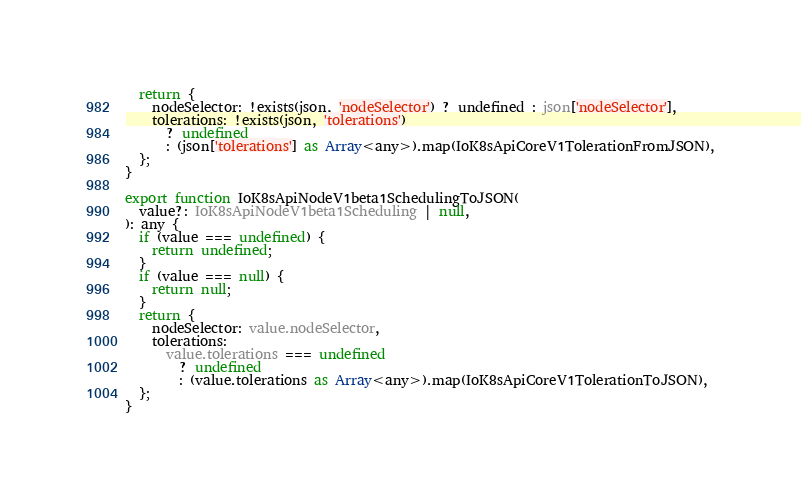Convert code to text. <code><loc_0><loc_0><loc_500><loc_500><_TypeScript_>  return {
    nodeSelector: !exists(json, 'nodeSelector') ? undefined : json['nodeSelector'],
    tolerations: !exists(json, 'tolerations')
      ? undefined
      : (json['tolerations'] as Array<any>).map(IoK8sApiCoreV1TolerationFromJSON),
  };
}

export function IoK8sApiNodeV1beta1SchedulingToJSON(
  value?: IoK8sApiNodeV1beta1Scheduling | null,
): any {
  if (value === undefined) {
    return undefined;
  }
  if (value === null) {
    return null;
  }
  return {
    nodeSelector: value.nodeSelector,
    tolerations:
      value.tolerations === undefined
        ? undefined
        : (value.tolerations as Array<any>).map(IoK8sApiCoreV1TolerationToJSON),
  };
}
</code> 